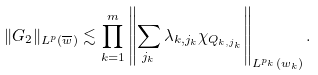Convert formula to latex. <formula><loc_0><loc_0><loc_500><loc_500>\| G _ { 2 } \| _ { L ^ { p } ( \overline { w } ) } \lesssim \prod _ { k = 1 } ^ { m } \left \| \sum _ { j _ { k } } { \lambda _ { k , j _ { k } } } \chi _ { Q _ { k , j _ { k } } } \right \| _ { L ^ { p _ { k } } ( w _ { k } ) } .</formula> 